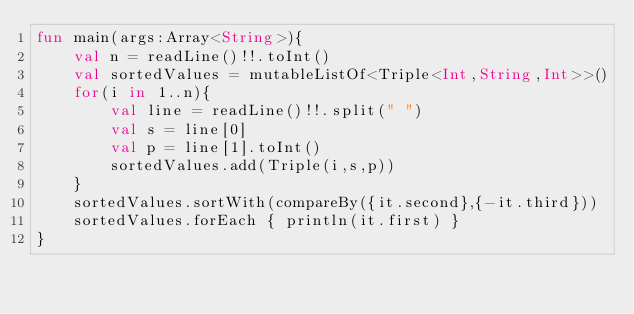Convert code to text. <code><loc_0><loc_0><loc_500><loc_500><_Kotlin_>fun main(args:Array<String>){
    val n = readLine()!!.toInt()
    val sortedValues = mutableListOf<Triple<Int,String,Int>>()
    for(i in 1..n){
        val line = readLine()!!.split(" ")
        val s = line[0]
        val p = line[1].toInt()
        sortedValues.add(Triple(i,s,p))
    }
    sortedValues.sortWith(compareBy({it.second},{-it.third}))
    sortedValues.forEach { println(it.first) }
}</code> 